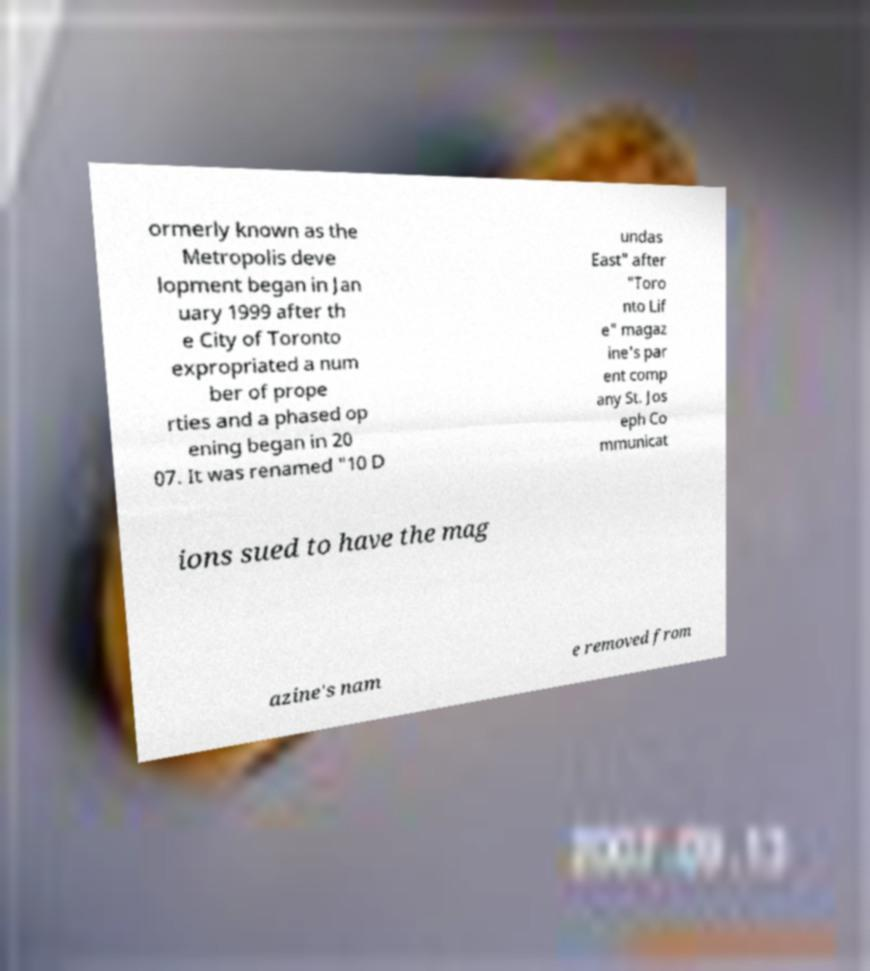I need the written content from this picture converted into text. Can you do that? ormerly known as the Metropolis deve lopment began in Jan uary 1999 after th e City of Toronto expropriated a num ber of prope rties and a phased op ening began in 20 07. It was renamed "10 D undas East" after "Toro nto Lif e" magaz ine's par ent comp any St. Jos eph Co mmunicat ions sued to have the mag azine's nam e removed from 